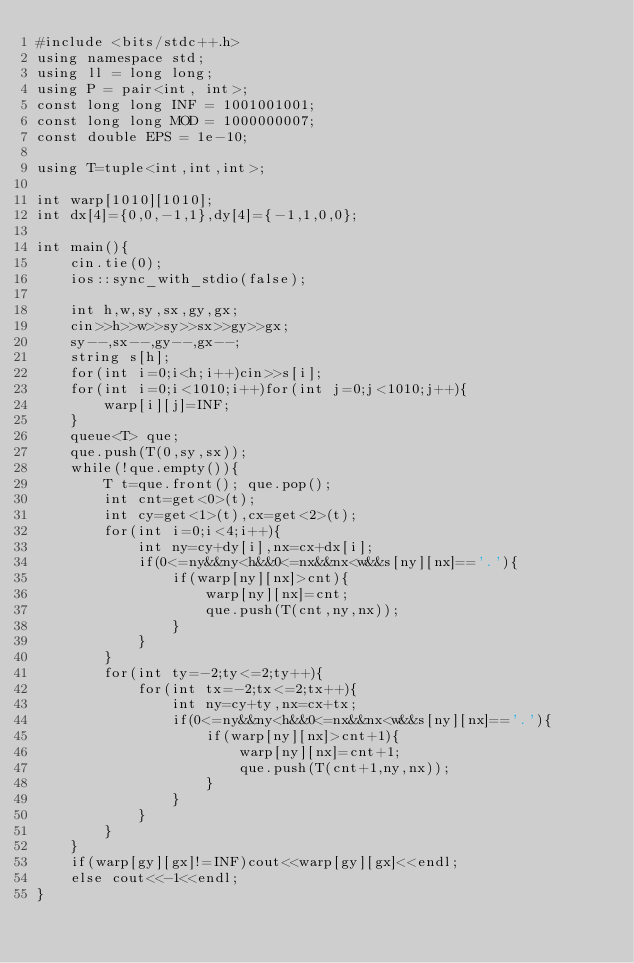Convert code to text. <code><loc_0><loc_0><loc_500><loc_500><_C++_>#include <bits/stdc++.h>
using namespace std;
using ll = long long;
using P = pair<int, int>;
const long long INF = 1001001001;
const long long MOD = 1000000007;
const double EPS = 1e-10;

using T=tuple<int,int,int>;

int warp[1010][1010];
int dx[4]={0,0,-1,1},dy[4]={-1,1,0,0};

int main(){
    cin.tie(0);
    ios::sync_with_stdio(false);

    int h,w,sy,sx,gy,gx;
    cin>>h>>w>>sy>>sx>>gy>>gx;
    sy--,sx--,gy--,gx--;
    string s[h];
    for(int i=0;i<h;i++)cin>>s[i];
    for(int i=0;i<1010;i++)for(int j=0;j<1010;j++){
        warp[i][j]=INF;
    }
    queue<T> que;
    que.push(T(0,sy,sx));
    while(!que.empty()){
        T t=que.front(); que.pop();
        int cnt=get<0>(t);
        int cy=get<1>(t),cx=get<2>(t);
        for(int i=0;i<4;i++){
            int ny=cy+dy[i],nx=cx+dx[i];
            if(0<=ny&&ny<h&&0<=nx&&nx<w&&s[ny][nx]=='.'){
                if(warp[ny][nx]>cnt){
                    warp[ny][nx]=cnt;
                    que.push(T(cnt,ny,nx));
                }
            }
        }
        for(int ty=-2;ty<=2;ty++){
            for(int tx=-2;tx<=2;tx++){
                int ny=cy+ty,nx=cx+tx;
                if(0<=ny&&ny<h&&0<=nx&&nx<w&&s[ny][nx]=='.'){
                    if(warp[ny][nx]>cnt+1){
                        warp[ny][nx]=cnt+1;
                        que.push(T(cnt+1,ny,nx));
                    }
                }
            }
        }
    }
    if(warp[gy][gx]!=INF)cout<<warp[gy][gx]<<endl;
    else cout<<-1<<endl;
}</code> 